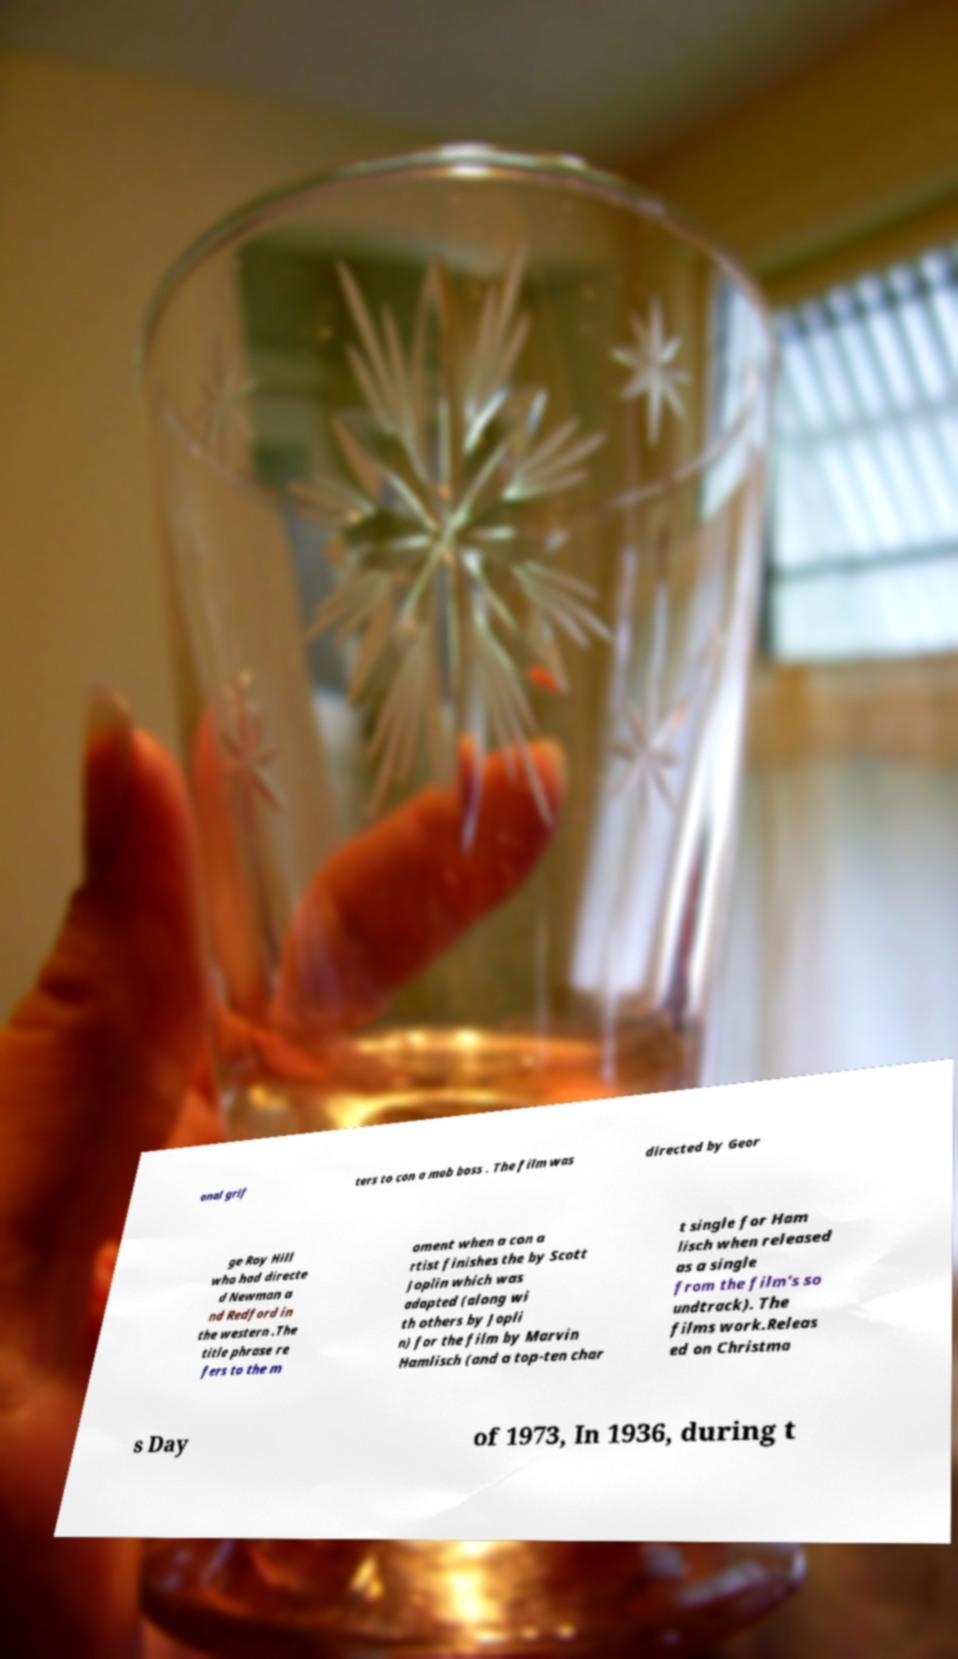Could you extract and type out the text from this image? onal grif ters to con a mob boss . The film was directed by Geor ge Roy Hill who had directe d Newman a nd Redford in the western .The title phrase re fers to the m oment when a con a rtist finishes the by Scott Joplin which was adapted (along wi th others by Jopli n) for the film by Marvin Hamlisch (and a top-ten char t single for Ham lisch when released as a single from the film's so undtrack). The films work.Releas ed on Christma s Day of 1973, In 1936, during t 